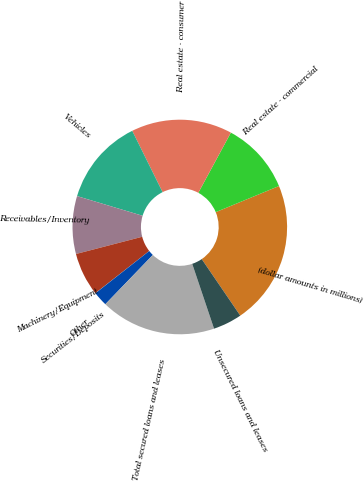<chart> <loc_0><loc_0><loc_500><loc_500><pie_chart><fcel>(dollar amounts in millions)<fcel>Real estate - commercial<fcel>Real estate - consumer<fcel>Vehicles<fcel>Receivables/Inventory<fcel>Machinery/Equipment<fcel>Securities/Deposits<fcel>Other<fcel>Total secured loans and leases<fcel>Unsecured loans and leases<nl><fcel>21.71%<fcel>10.87%<fcel>15.21%<fcel>13.04%<fcel>8.7%<fcel>6.53%<fcel>0.02%<fcel>2.19%<fcel>17.38%<fcel>4.36%<nl></chart> 